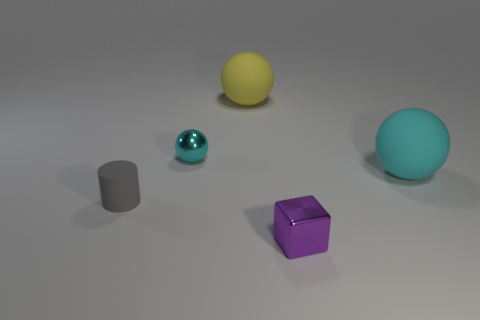Add 4 big gray rubber blocks. How many objects exist? 9 Subtract all balls. How many objects are left? 2 Subtract 0 brown cylinders. How many objects are left? 5 Subtract all small rubber objects. Subtract all rubber objects. How many objects are left? 1 Add 2 cyan rubber things. How many cyan rubber things are left? 3 Add 2 cyan matte things. How many cyan matte things exist? 3 